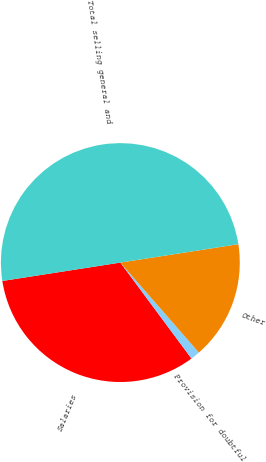Convert chart. <chart><loc_0><loc_0><loc_500><loc_500><pie_chart><fcel>Salaries<fcel>Provision for doubtful<fcel>Other<fcel>Total selling general and<nl><fcel>32.69%<fcel>1.27%<fcel>16.04%<fcel>50.0%<nl></chart> 